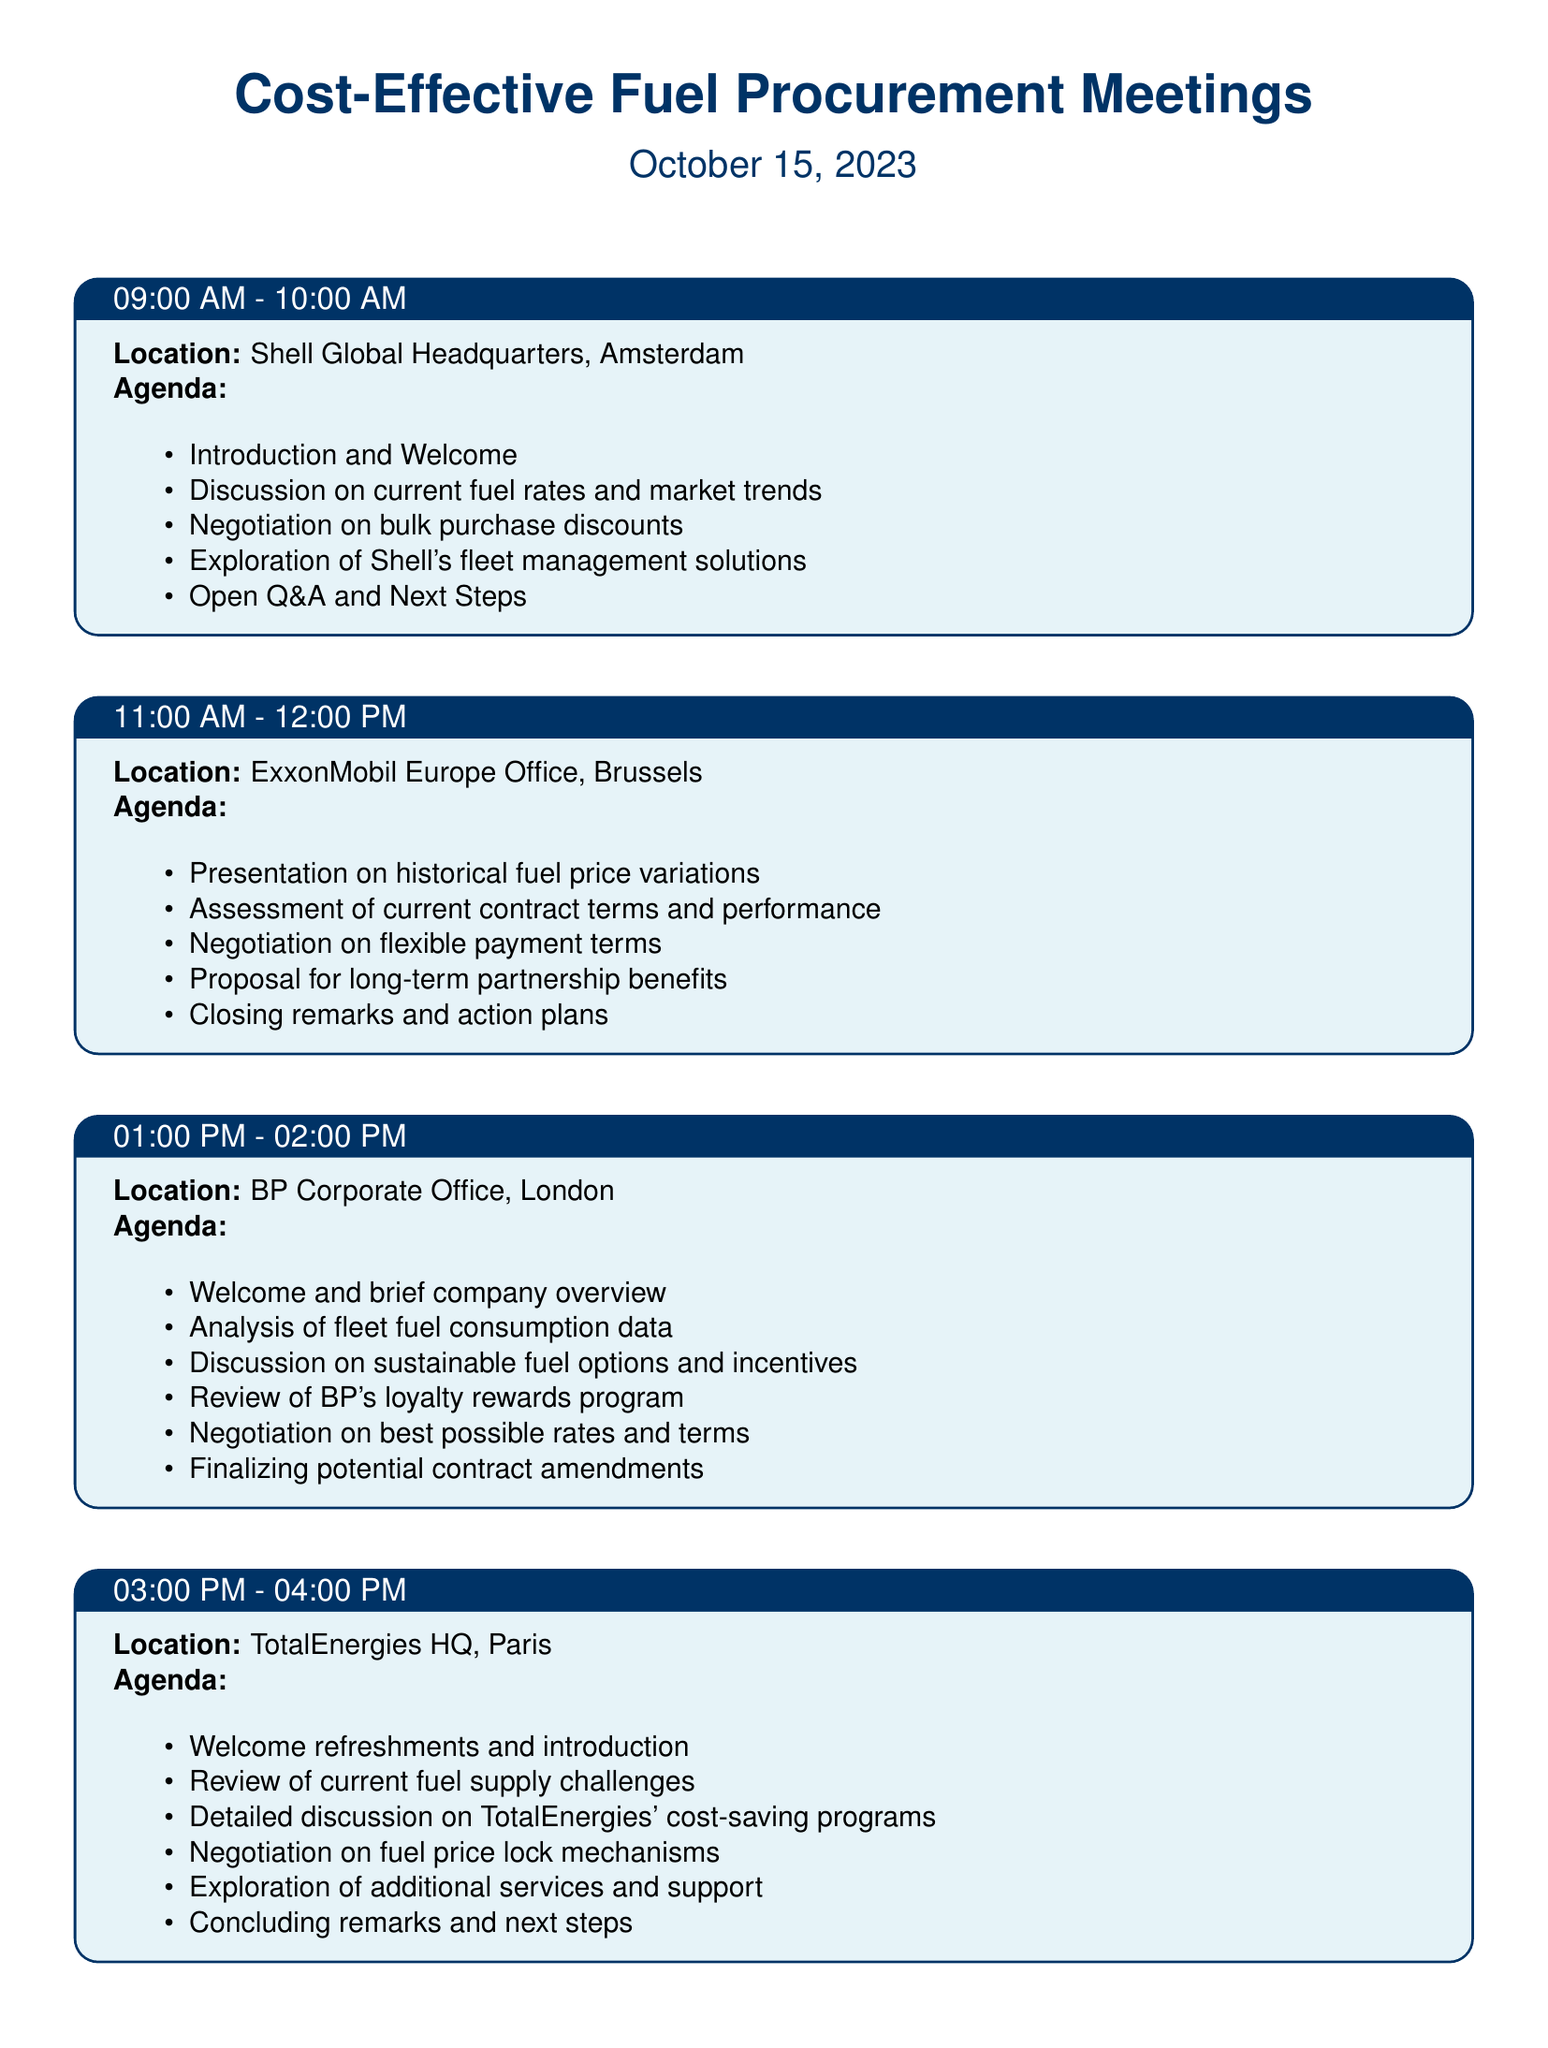What time does the meeting with Shell take place? The meeting with Shell is scheduled from 09:00 AM to 10:00 AM.
Answer: 09:00 AM - 10:00 AM What is the location of the ExxonMobil meeting? The meeting with ExxonMobil is held at the ExxonMobil Europe Office in Brussels.
Answer: ExxonMobil Europe Office, Brussels What is one agenda point for the BP Corporate Office meeting? One agenda point includes the negotiation on best possible rates and terms.
Answer: Negotiation on best possible rates and terms How many total meetings are scheduled in the document? There are four meetings scheduled in the itinerary.
Answer: Four What is discussed during the TotalEnergies meeting? The TotalEnergies meeting discusses fuel supply challenges and cost-saving programs.
Answer: Fuel supply challenges and cost-saving programs Which company is exploring fleet management solutions? Shell is exploring fleet management solutions during its meeting.
Answer: Shell What is one of the negotiation items with ExxonMobil? One of the negotiation items is flexible payment terms.
Answer: Flexible payment terms Where is the TotalEnergies meeting located? The TotalEnergies meeting takes place at TotalEnergies HQ in Paris.
Answer: TotalEnergies HQ, Paris 